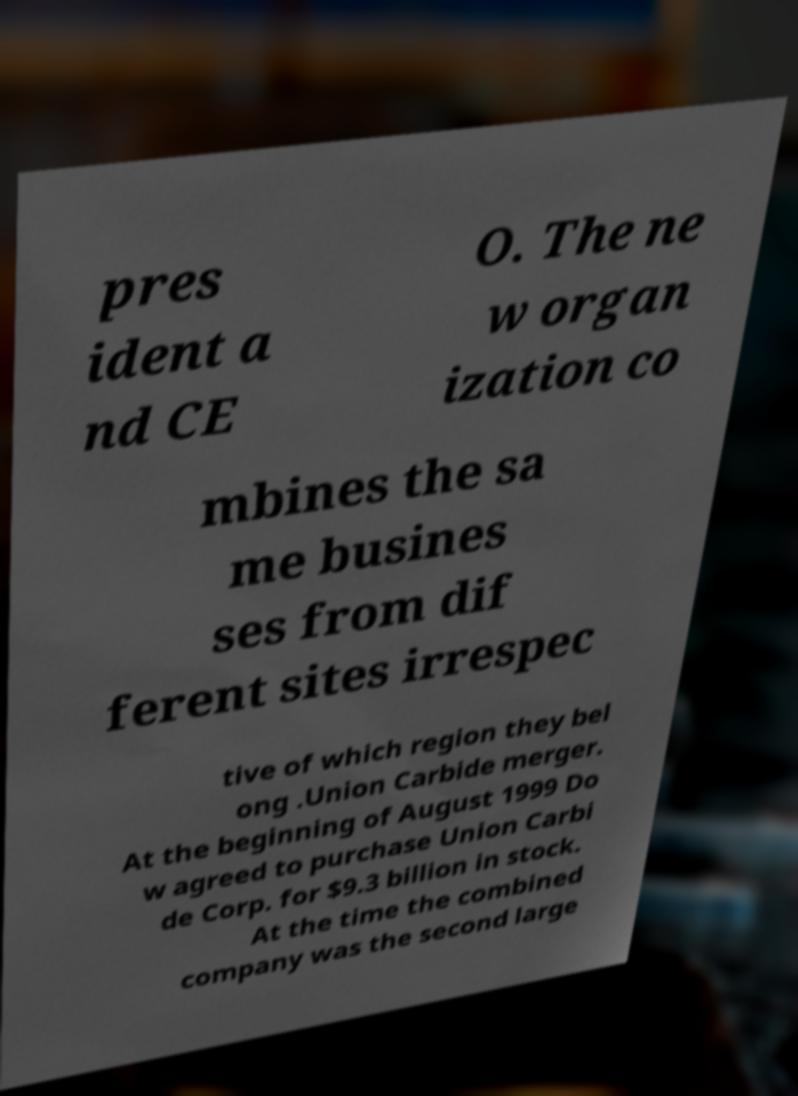Please read and relay the text visible in this image. What does it say? pres ident a nd CE O. The ne w organ ization co mbines the sa me busines ses from dif ferent sites irrespec tive of which region they bel ong .Union Carbide merger. At the beginning of August 1999 Do w agreed to purchase Union Carbi de Corp. for $9.3 billion in stock. At the time the combined company was the second large 